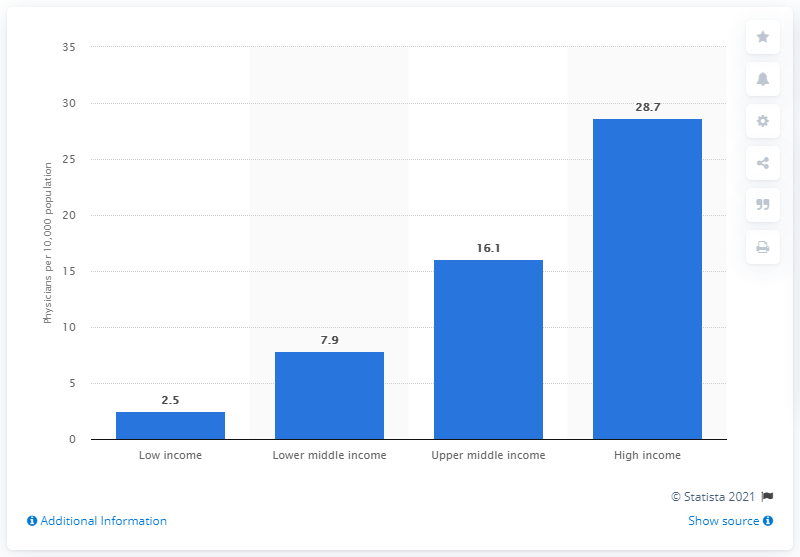Specify some key components in this picture. In the low income class, the average number of physicians per 10,000 inhabitants was 2.5. 